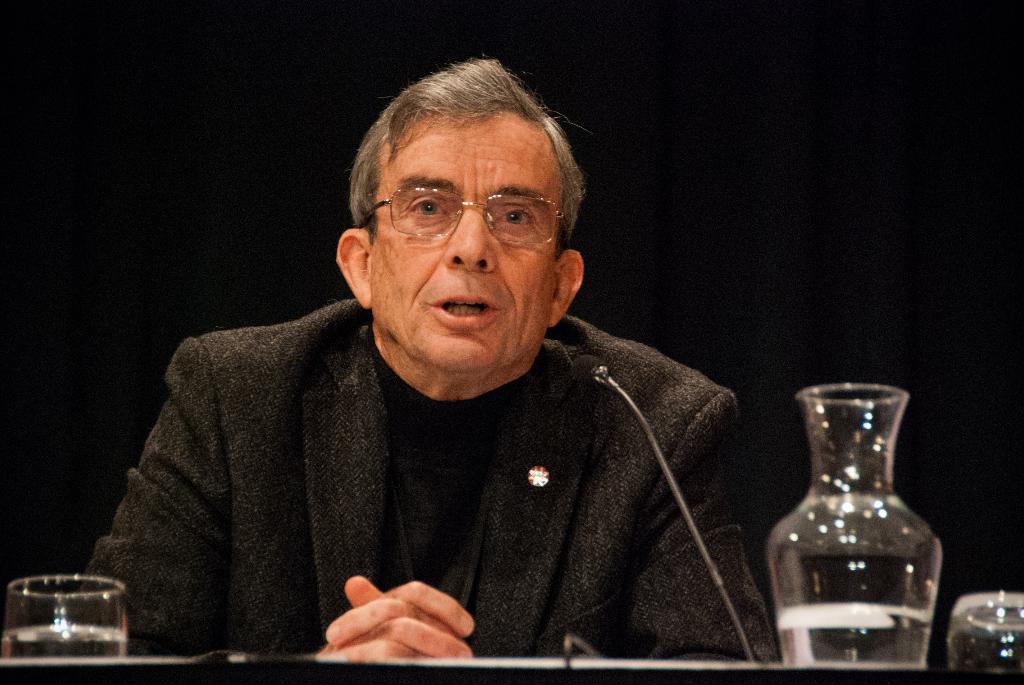In one or two sentences, can you explain what this image depicts? At the bottom of the image on the surface there is a glass with water, jar with water and also there is a mic. Behind them there is a man with spectacles. And there is a black background. 